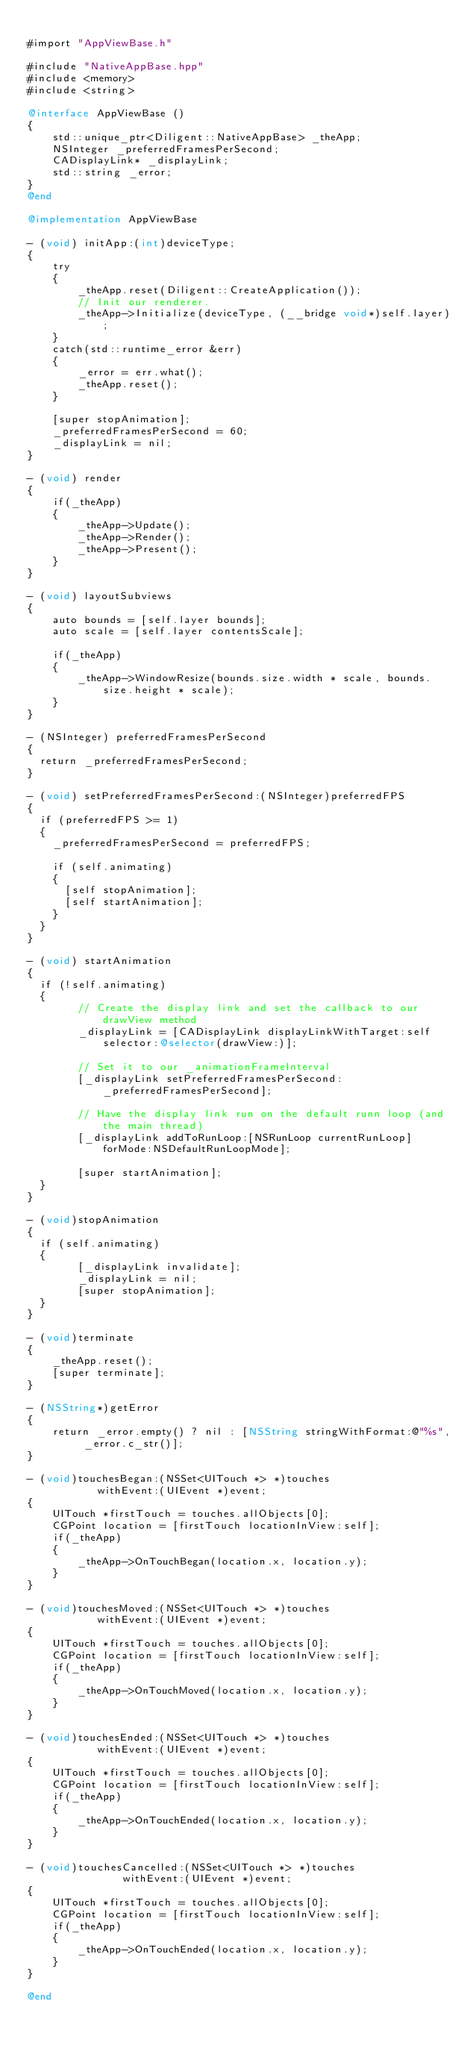<code> <loc_0><loc_0><loc_500><loc_500><_ObjectiveC_>
#import "AppViewBase.h"

#include "NativeAppBase.hpp"
#include <memory>
#include <string>

@interface AppViewBase ()
{
    std::unique_ptr<Diligent::NativeAppBase> _theApp;
    NSInteger _preferredFramesPerSecond;
    CADisplayLink* _displayLink;
    std::string _error;
}
@end

@implementation AppViewBase

- (void) initApp:(int)deviceType;
{
    try
    {
        _theApp.reset(Diligent::CreateApplication());
        // Init our renderer.
        _theApp->Initialize(deviceType, (__bridge void*)self.layer);
    }
    catch(std::runtime_error &err)
    {
        _error = err.what();
        _theApp.reset();
    }

    [super stopAnimation];
    _preferredFramesPerSecond = 60;
    _displayLink = nil;
}

- (void) render
{
    if(_theApp)
    {
        _theApp->Update();
        _theApp->Render();
        _theApp->Present();
    }
}

- (void) layoutSubviews
{
    auto bounds = [self.layer bounds];
    auto scale = [self.layer contentsScale];

    if(_theApp)
    {
        _theApp->WindowResize(bounds.size.width * scale, bounds.size.height * scale);
    }
}

- (NSInteger) preferredFramesPerSecond
{
	return _preferredFramesPerSecond;
}

- (void) setPreferredFramesPerSecond:(NSInteger)preferredFPS
{
	if (preferredFPS >= 1)
	{
		_preferredFramesPerSecond = preferredFPS;

		if (self.animating)
		{
			[self stopAnimation];
			[self startAnimation];
		}
	}
}

- (void) startAnimation
{
	if (!self.animating)
	{
        // Create the display link and set the callback to our drawView method
        _displayLink = [CADisplayLink displayLinkWithTarget:self selector:@selector(drawView:)];

        // Set it to our _animationFrameInterval
        [_displayLink setPreferredFramesPerSecond:_preferredFramesPerSecond];

        // Have the display link run on the default runn loop (and the main thread)
        [_displayLink addToRunLoop:[NSRunLoop currentRunLoop] forMode:NSDefaultRunLoopMode];

        [super startAnimation];
	}
}

- (void)stopAnimation
{
	if (self.animating)
	{
        [_displayLink invalidate];
        _displayLink = nil;
        [super stopAnimation];
	}
}

- (void)terminate
{
    _theApp.reset();
    [super terminate];
}

- (NSString*)getError
{
    return _error.empty() ? nil : [NSString stringWithFormat:@"%s", _error.c_str()];
}

- (void)touchesBegan:(NSSet<UITouch *> *)touches
           withEvent:(UIEvent *)event;
{
    UITouch *firstTouch = touches.allObjects[0];
    CGPoint location = [firstTouch locationInView:self];
    if(_theApp)
    {
        _theApp->OnTouchBegan(location.x, location.y);
    }
}

- (void)touchesMoved:(NSSet<UITouch *> *)touches
           withEvent:(UIEvent *)event;
{
    UITouch *firstTouch = touches.allObjects[0];
    CGPoint location = [firstTouch locationInView:self];
    if(_theApp)
    {
        _theApp->OnTouchMoved(location.x, location.y);
    }
}

- (void)touchesEnded:(NSSet<UITouch *> *)touches
           withEvent:(UIEvent *)event;
{
    UITouch *firstTouch = touches.allObjects[0];
    CGPoint location = [firstTouch locationInView:self];
    if(_theApp)
    {
        _theApp->OnTouchEnded(location.x, location.y);
    }
}

- (void)touchesCancelled:(NSSet<UITouch *> *)touches
               withEvent:(UIEvent *)event;
{
    UITouch *firstTouch = touches.allObjects[0];
    CGPoint location = [firstTouch locationInView:self];
    if(_theApp)
    {
        _theApp->OnTouchEnded(location.x, location.y);
    }
}

@end
</code> 